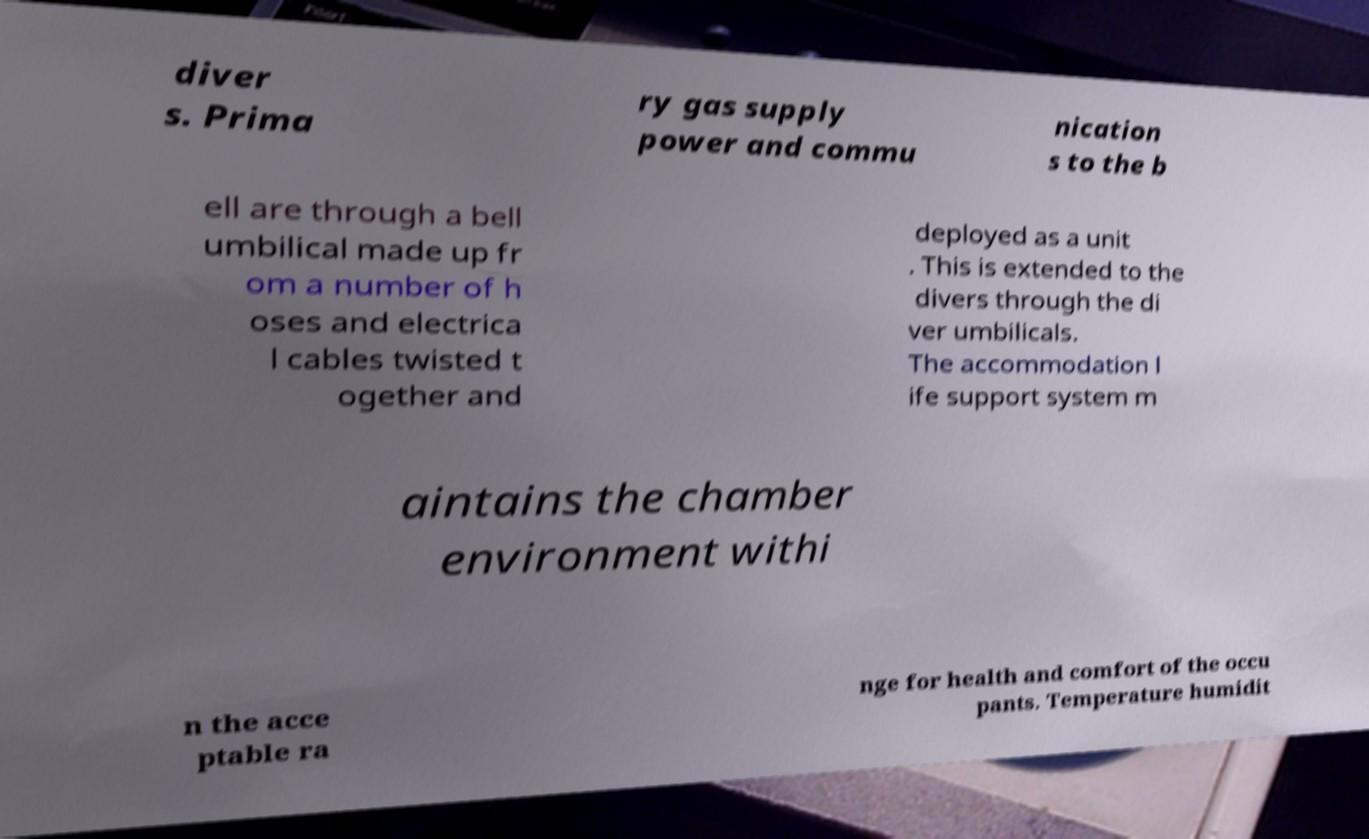Could you extract and type out the text from this image? diver s. Prima ry gas supply power and commu nication s to the b ell are through a bell umbilical made up fr om a number of h oses and electrica l cables twisted t ogether and deployed as a unit . This is extended to the divers through the di ver umbilicals. The accommodation l ife support system m aintains the chamber environment withi n the acce ptable ra nge for health and comfort of the occu pants. Temperature humidit 